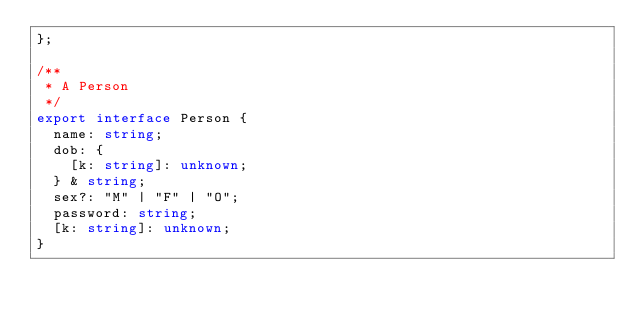<code> <loc_0><loc_0><loc_500><loc_500><_TypeScript_>};

/**
 * A Person
 */
export interface Person {
  name: string;
  dob: {
    [k: string]: unknown;
  } & string;
  sex?: "M" | "F" | "O";
  password: string;
  [k: string]: unknown;
}
</code> 